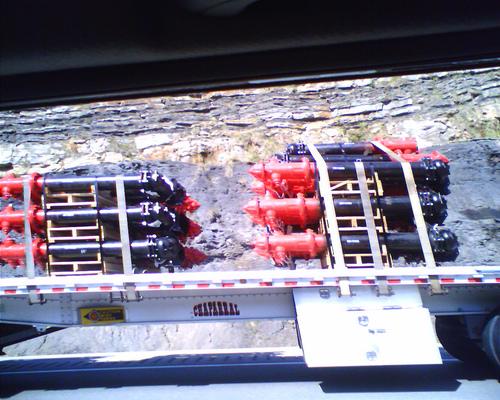Was this picture made from a vehicle?
Quick response, please. No. What is the trailer attached to?
Short answer required. Truck. Which local department needs the contents of this trailer?
Be succinct. Fire. 